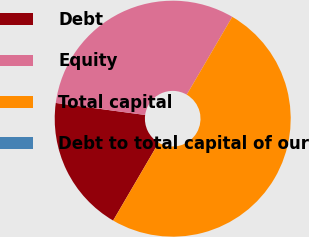Convert chart. <chart><loc_0><loc_0><loc_500><loc_500><pie_chart><fcel>Debt<fcel>Equity<fcel>Total capital<fcel>Debt to total capital of our<nl><fcel>18.71%<fcel>31.29%<fcel>50.0%<fcel>0.0%<nl></chart> 